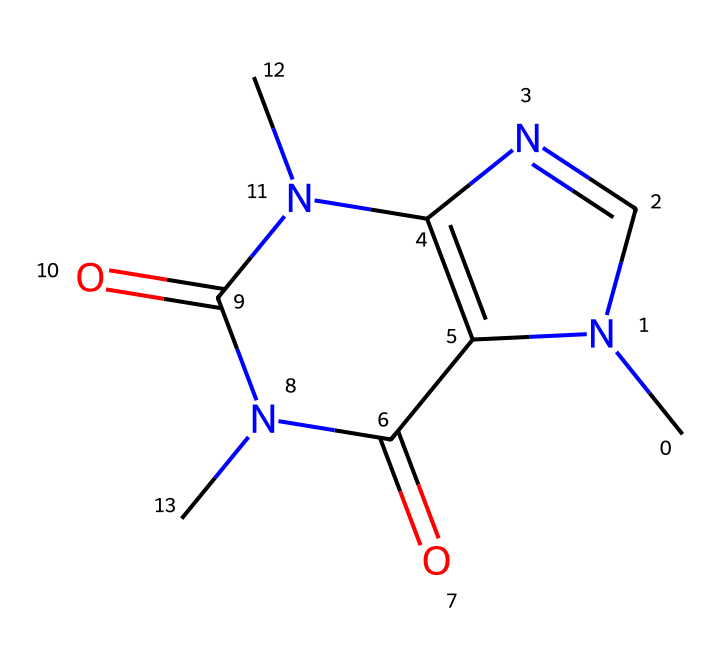What is the molecular formula of caffeine? To find the molecular formula, count the number of each type of atom represented in the structure. From the SMILES, we have Carbon (C) as 8, Hydrogen (H) as 10, Nitrogen (N) as 4, and Oxygen (O) as 2. Thus, the molecular formula is C8H10N4O2.
Answer: C8H10N4O2 How many rings are present in the caffeine structure? The structure contains two fusion rings, which are visible in the arrangement of the atoms in the SMILES. These rings indicate a bicyclic structure.
Answer: 2 What is the significance of the nitrogen atoms in caffeine? The nitrogen atoms are crucial as they influence the basicity and bioactivity of caffeine. They are part of the heterocyclic rings and contribute to the stimulant effects associated with caffeine.
Answer: bioactivity What is the total number of double bonds in caffeine? By analyzing the SMILES representation, there are two double bonds located in the carbonyl groups connected to nitrogen atoms. Count each double bond to find the total.
Answer: 2 What type of solid is caffeine, given its chemical structure? Caffeine is classified as a crystalline solid due to its well-organized and repeating structure at the molecular level. It forms crystals when solidified.
Answer: crystalline What functional groups are present in caffeine? The primary functional groups in caffeine include amine groups (due to nitrogen) and carbonyl groups (due to the presence of -C=O structures). Identifying these groups gives insight into its reactivity and properties.
Answer: amine, carbonyl 